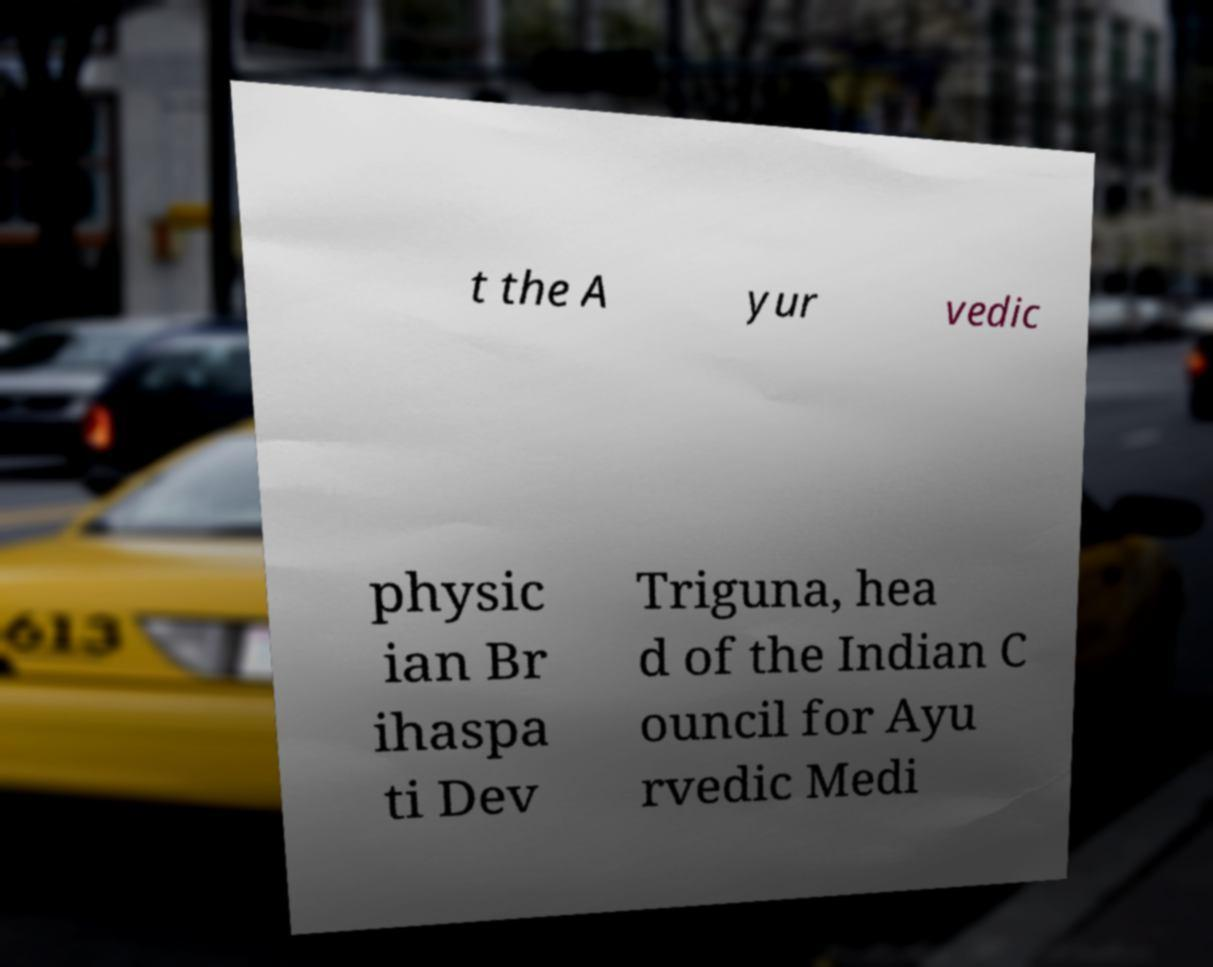Please read and relay the text visible in this image. What does it say? t the A yur vedic physic ian Br ihaspa ti Dev Triguna, hea d of the Indian C ouncil for Ayu rvedic Medi 